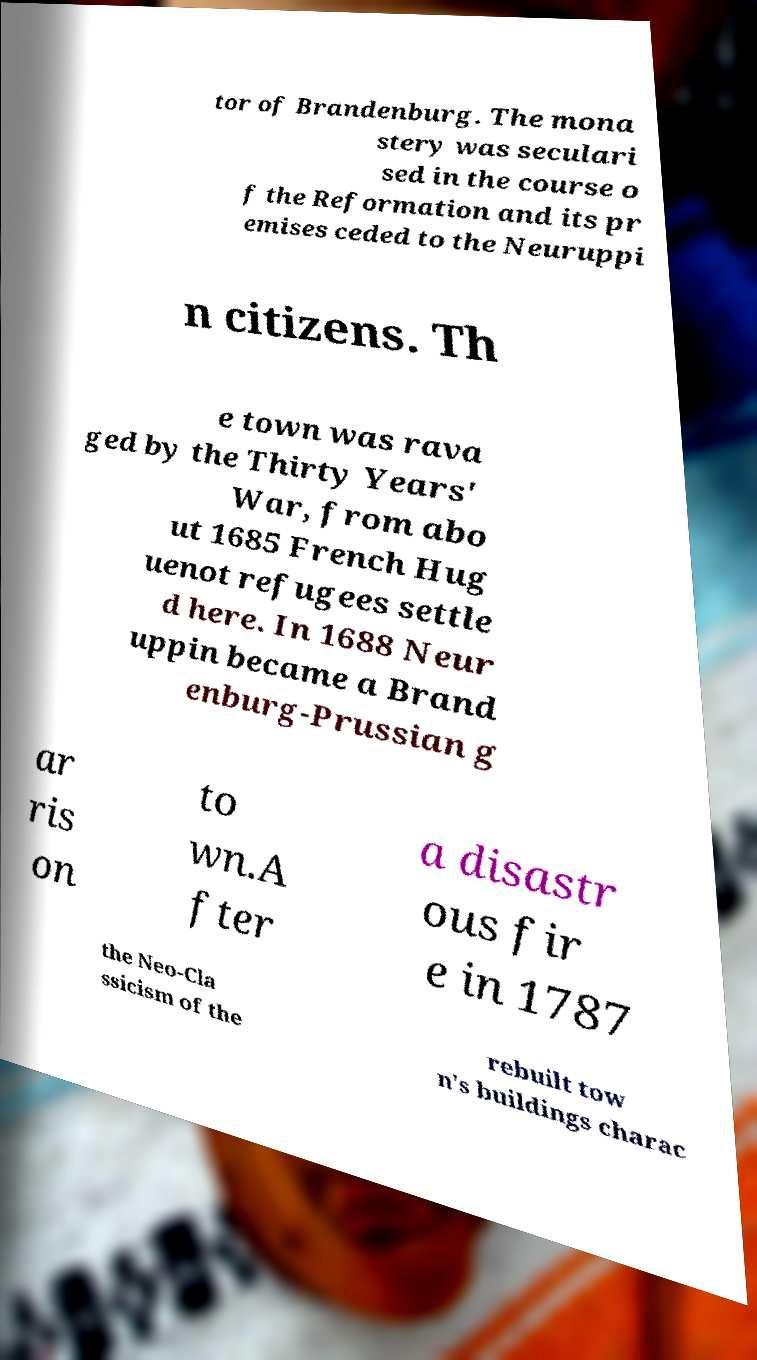There's text embedded in this image that I need extracted. Can you transcribe it verbatim? tor of Brandenburg. The mona stery was seculari sed in the course o f the Reformation and its pr emises ceded to the Neuruppi n citizens. Th e town was rava ged by the Thirty Years' War, from abo ut 1685 French Hug uenot refugees settle d here. In 1688 Neur uppin became a Brand enburg-Prussian g ar ris on to wn.A fter a disastr ous fir e in 1787 the Neo-Cla ssicism of the rebuilt tow n's buildings charac 